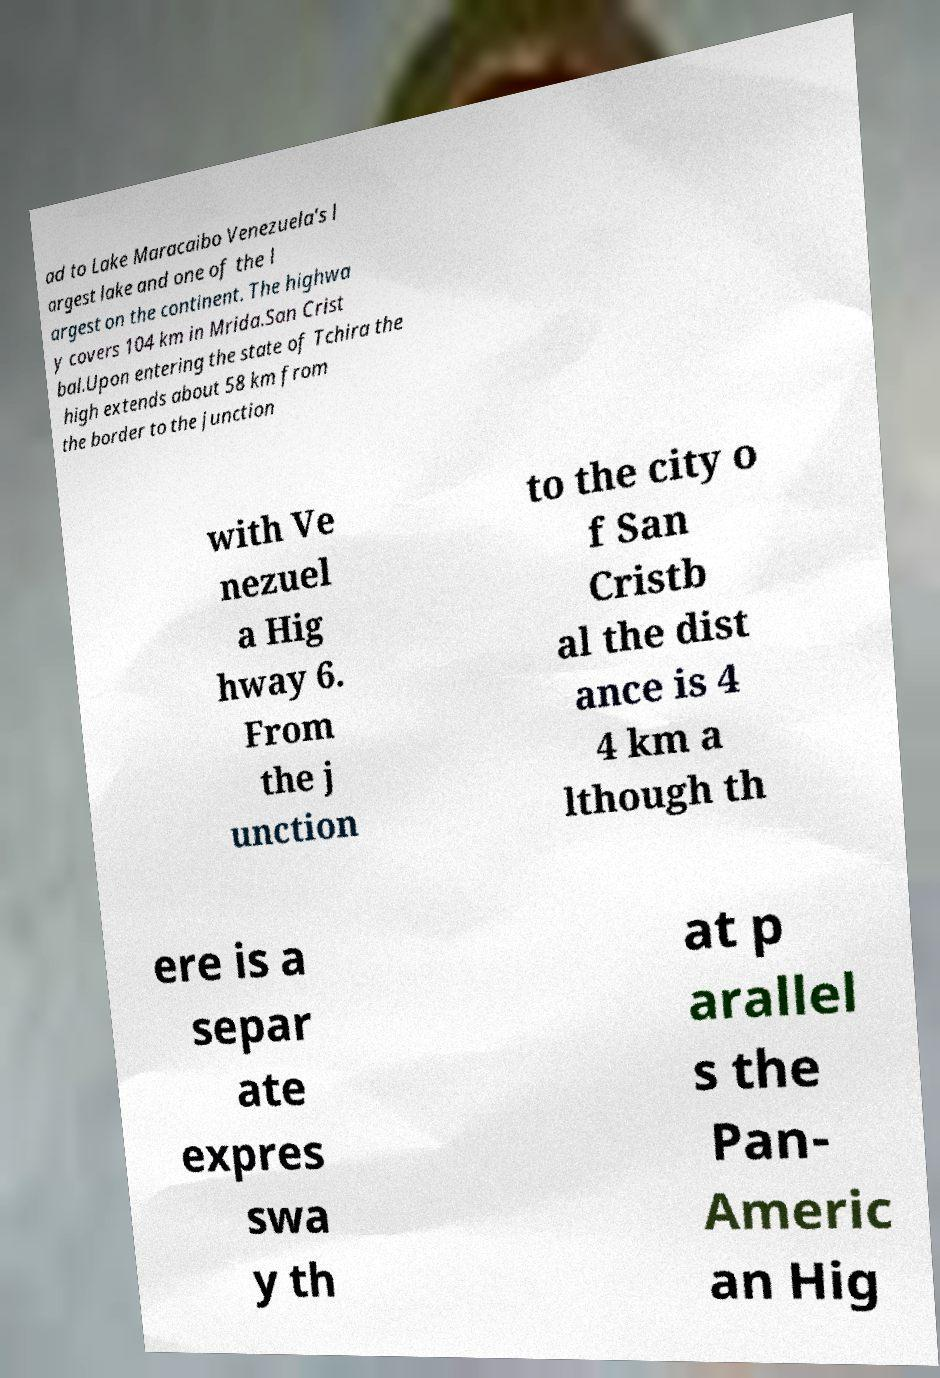Please read and relay the text visible in this image. What does it say? ad to Lake Maracaibo Venezuela's l argest lake and one of the l argest on the continent. The highwa y covers 104 km in Mrida.San Crist bal.Upon entering the state of Tchira the high extends about 58 km from the border to the junction with Ve nezuel a Hig hway 6. From the j unction to the city o f San Cristb al the dist ance is 4 4 km a lthough th ere is a separ ate expres swa y th at p arallel s the Pan- Americ an Hig 